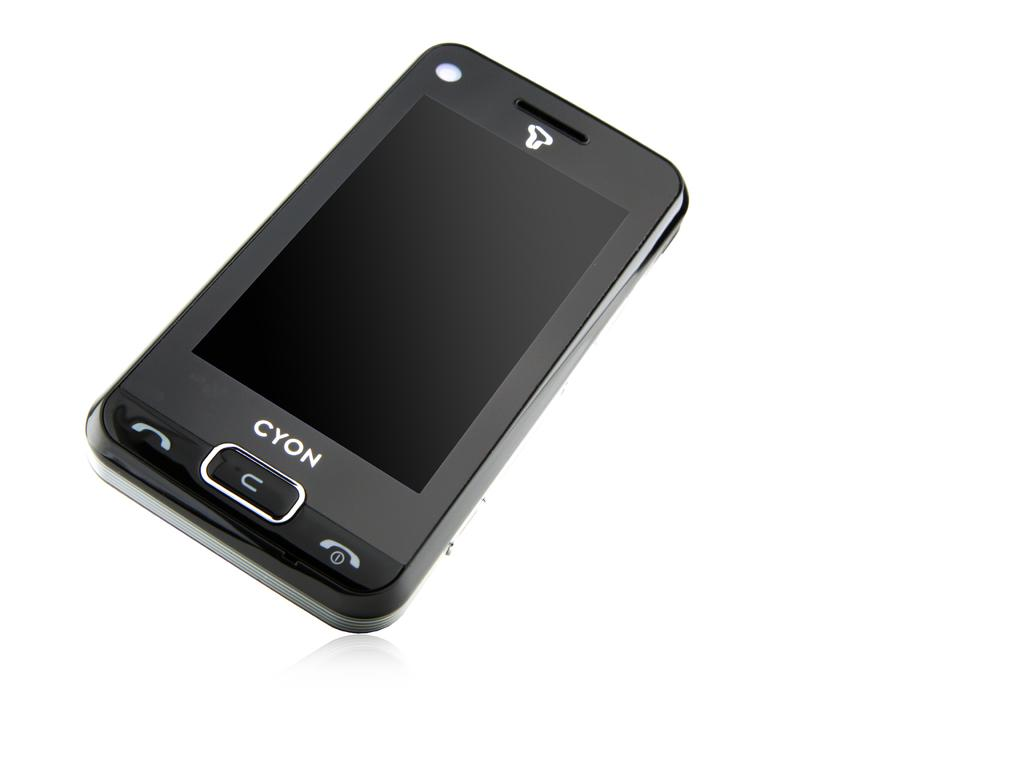<image>
Create a compact narrative representing the image presented. a black cell phone named Cyon has very few buttons 